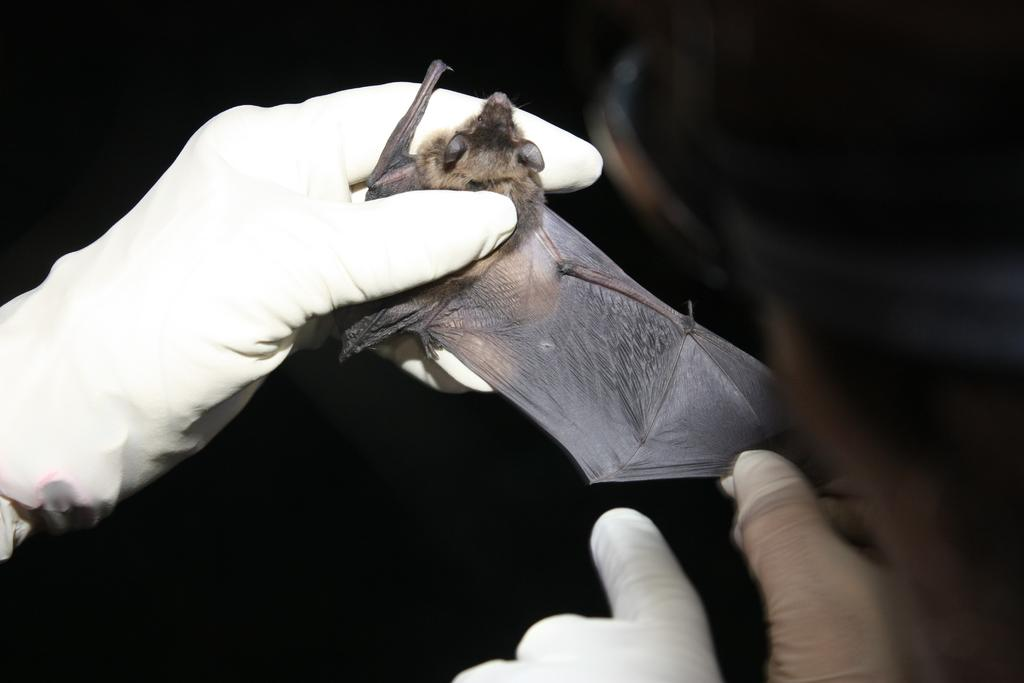What is being held by the hands in the image? The hands are holding a bat in the image. Are the hands wearing any protective gear? Yes, the hands are wearing a glove. What can be observed about the background of the image? The background of the image is dark. What type of tax is being discussed in the image? There is no discussion of tax in the image; it features hands holding a bat with gloves on. 